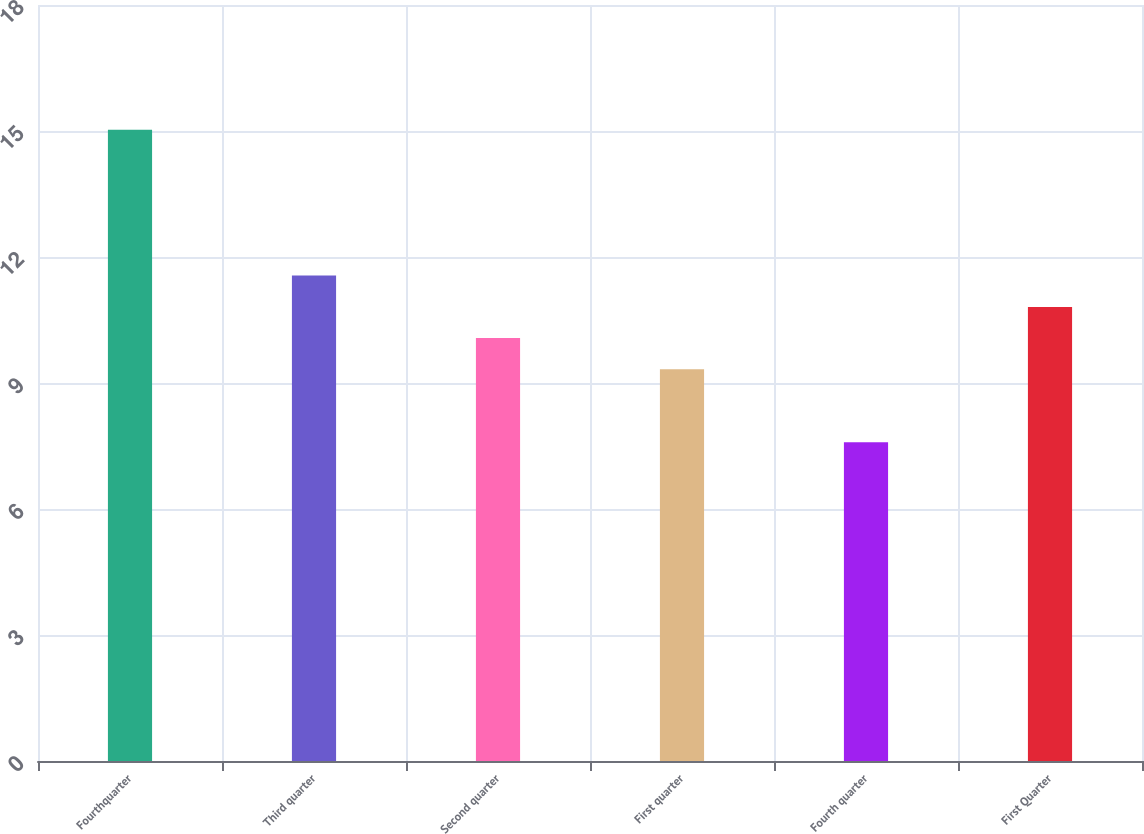Convert chart. <chart><loc_0><loc_0><loc_500><loc_500><bar_chart><fcel>Fourthquarter<fcel>Third quarter<fcel>Second quarter<fcel>First quarter<fcel>Fourth quarter<fcel>First Quarter<nl><fcel>15.03<fcel>11.56<fcel>10.07<fcel>9.33<fcel>7.59<fcel>10.81<nl></chart> 